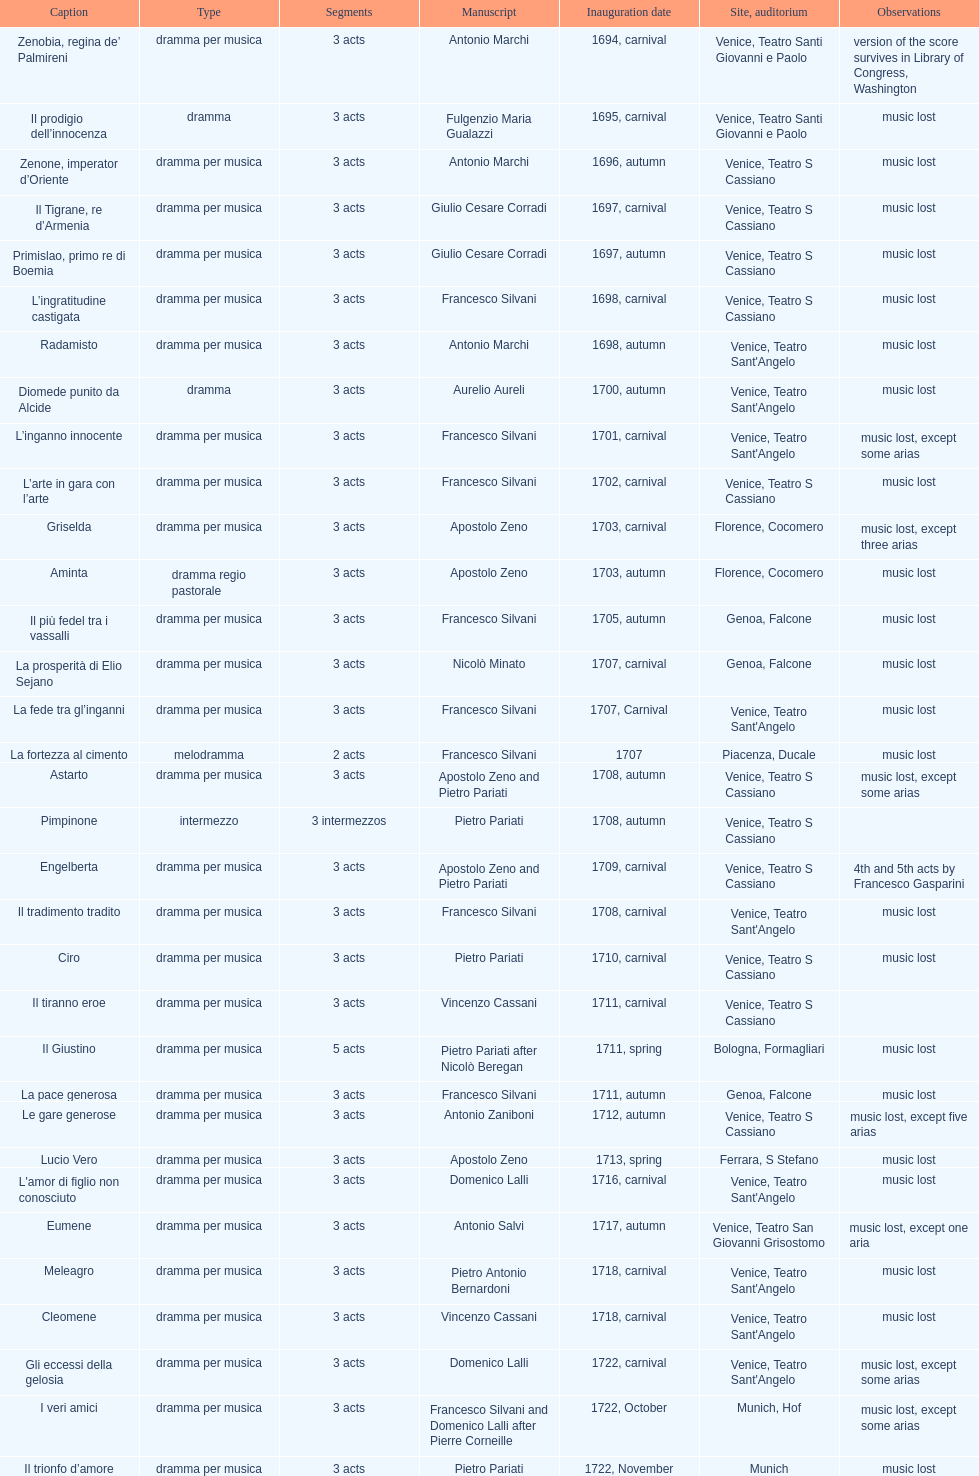I'm looking to parse the entire table for insights. Could you assist me with that? {'header': ['Caption', 'Type', 'Segments', 'Manuscript', 'Inauguration date', 'Site, auditorium', 'Observations'], 'rows': [['Zenobia, regina de’ Palmireni', 'dramma per musica', '3 acts', 'Antonio Marchi', '1694, carnival', 'Venice, Teatro Santi Giovanni e Paolo', 'version of the score survives in Library of Congress, Washington'], ['Il prodigio dell’innocenza', 'dramma', '3 acts', 'Fulgenzio Maria Gualazzi', '1695, carnival', 'Venice, Teatro Santi Giovanni e Paolo', 'music lost'], ['Zenone, imperator d’Oriente', 'dramma per musica', '3 acts', 'Antonio Marchi', '1696, autumn', 'Venice, Teatro S Cassiano', 'music lost'], ['Il Tigrane, re d’Armenia', 'dramma per musica', '3 acts', 'Giulio Cesare Corradi', '1697, carnival', 'Venice, Teatro S Cassiano', 'music lost'], ['Primislao, primo re di Boemia', 'dramma per musica', '3 acts', 'Giulio Cesare Corradi', '1697, autumn', 'Venice, Teatro S Cassiano', 'music lost'], ['L’ingratitudine castigata', 'dramma per musica', '3 acts', 'Francesco Silvani', '1698, carnival', 'Venice, Teatro S Cassiano', 'music lost'], ['Radamisto', 'dramma per musica', '3 acts', 'Antonio Marchi', '1698, autumn', "Venice, Teatro Sant'Angelo", 'music lost'], ['Diomede punito da Alcide', 'dramma', '3 acts', 'Aurelio Aureli', '1700, autumn', "Venice, Teatro Sant'Angelo", 'music lost'], ['L’inganno innocente', 'dramma per musica', '3 acts', 'Francesco Silvani', '1701, carnival', "Venice, Teatro Sant'Angelo", 'music lost, except some arias'], ['L’arte in gara con l’arte', 'dramma per musica', '3 acts', 'Francesco Silvani', '1702, carnival', 'Venice, Teatro S Cassiano', 'music lost'], ['Griselda', 'dramma per musica', '3 acts', 'Apostolo Zeno', '1703, carnival', 'Florence, Cocomero', 'music lost, except three arias'], ['Aminta', 'dramma regio pastorale', '3 acts', 'Apostolo Zeno', '1703, autumn', 'Florence, Cocomero', 'music lost'], ['Il più fedel tra i vassalli', 'dramma per musica', '3 acts', 'Francesco Silvani', '1705, autumn', 'Genoa, Falcone', 'music lost'], ['La prosperità di Elio Sejano', 'dramma per musica', '3 acts', 'Nicolò Minato', '1707, carnival', 'Genoa, Falcone', 'music lost'], ['La fede tra gl’inganni', 'dramma per musica', '3 acts', 'Francesco Silvani', '1707, Carnival', "Venice, Teatro Sant'Angelo", 'music lost'], ['La fortezza al cimento', 'melodramma', '2 acts', 'Francesco Silvani', '1707', 'Piacenza, Ducale', 'music lost'], ['Astarto', 'dramma per musica', '3 acts', 'Apostolo Zeno and Pietro Pariati', '1708, autumn', 'Venice, Teatro S Cassiano', 'music lost, except some arias'], ['Pimpinone', 'intermezzo', '3 intermezzos', 'Pietro Pariati', '1708, autumn', 'Venice, Teatro S Cassiano', ''], ['Engelberta', 'dramma per musica', '3 acts', 'Apostolo Zeno and Pietro Pariati', '1709, carnival', 'Venice, Teatro S Cassiano', '4th and 5th acts by Francesco Gasparini'], ['Il tradimento tradito', 'dramma per musica', '3 acts', 'Francesco Silvani', '1708, carnival', "Venice, Teatro Sant'Angelo", 'music lost'], ['Ciro', 'dramma per musica', '3 acts', 'Pietro Pariati', '1710, carnival', 'Venice, Teatro S Cassiano', 'music lost'], ['Il tiranno eroe', 'dramma per musica', '3 acts', 'Vincenzo Cassani', '1711, carnival', 'Venice, Teatro S Cassiano', ''], ['Il Giustino', 'dramma per musica', '5 acts', 'Pietro Pariati after Nicolò Beregan', '1711, spring', 'Bologna, Formagliari', 'music lost'], ['La pace generosa', 'dramma per musica', '3 acts', 'Francesco Silvani', '1711, autumn', 'Genoa, Falcone', 'music lost'], ['Le gare generose', 'dramma per musica', '3 acts', 'Antonio Zaniboni', '1712, autumn', 'Venice, Teatro S Cassiano', 'music lost, except five arias'], ['Lucio Vero', 'dramma per musica', '3 acts', 'Apostolo Zeno', '1713, spring', 'Ferrara, S Stefano', 'music lost'], ["L'amor di figlio non conosciuto", 'dramma per musica', '3 acts', 'Domenico Lalli', '1716, carnival', "Venice, Teatro Sant'Angelo", 'music lost'], ['Eumene', 'dramma per musica', '3 acts', 'Antonio Salvi', '1717, autumn', 'Venice, Teatro San Giovanni Grisostomo', 'music lost, except one aria'], ['Meleagro', 'dramma per musica', '3 acts', 'Pietro Antonio Bernardoni', '1718, carnival', "Venice, Teatro Sant'Angelo", 'music lost'], ['Cleomene', 'dramma per musica', '3 acts', 'Vincenzo Cassani', '1718, carnival', "Venice, Teatro Sant'Angelo", 'music lost'], ['Gli eccessi della gelosia', 'dramma per musica', '3 acts', 'Domenico Lalli', '1722, carnival', "Venice, Teatro Sant'Angelo", 'music lost, except some arias'], ['I veri amici', 'dramma per musica', '3 acts', 'Francesco Silvani and Domenico Lalli after Pierre Corneille', '1722, October', 'Munich, Hof', 'music lost, except some arias'], ['Il trionfo d’amore', 'dramma per musica', '3 acts', 'Pietro Pariati', '1722, November', 'Munich', 'music lost'], ['Eumene', 'dramma per musica', '3 acts', 'Apostolo Zeno', '1723, carnival', 'Venice, Teatro San Moisè', 'music lost, except 2 arias'], ['Ermengarda', 'dramma per musica', '3 acts', 'Antonio Maria Lucchini', '1723, autumn', 'Venice, Teatro San Moisè', 'music lost'], ['Antigono, tutore di Filippo, re di Macedonia', 'tragedia', '5 acts', 'Giovanni Piazzon', '1724, carnival', 'Venice, Teatro San Moisè', '5th act by Giovanni Porta, music lost'], ['Scipione nelle Spagne', 'dramma per musica', '3 acts', 'Apostolo Zeno', '1724, Ascension', 'Venice, Teatro San Samuele', 'music lost'], ['Laodice', 'dramma per musica', '3 acts', 'Angelo Schietti', '1724, autumn', 'Venice, Teatro San Moisè', 'music lost, except 2 arias'], ['Didone abbandonata', 'tragedia', '3 acts', 'Metastasio', '1725, carnival', 'Venice, Teatro S Cassiano', 'music lost'], ["L'impresario delle Isole Canarie", 'intermezzo', '2 acts', 'Metastasio', '1725, carnival', 'Venice, Teatro S Cassiano', 'music lost'], ['Alcina delusa da Ruggero', 'dramma per musica', '3 acts', 'Antonio Marchi', '1725, autumn', 'Venice, Teatro S Cassiano', 'music lost'], ['I rivali generosi', 'dramma per musica', '3 acts', 'Apostolo Zeno', '1725', 'Brescia, Nuovo', ''], ['La Statira', 'dramma per musica', '3 acts', 'Apostolo Zeno and Pietro Pariati', '1726, Carnival', 'Rome, Teatro Capranica', ''], ['Malsazio e Fiammetta', 'intermezzo', '', '', '1726, Carnival', 'Rome, Teatro Capranica', ''], ['Il trionfo di Armida', 'dramma per musica', '3 acts', 'Girolamo Colatelli after Torquato Tasso', '1726, autumn', 'Venice, Teatro San Moisè', 'music lost'], ['L’incostanza schernita', 'dramma comico-pastorale', '3 acts', 'Vincenzo Cassani', '1727, Ascension', 'Venice, Teatro San Samuele', 'music lost, except some arias'], ['Le due rivali in amore', 'dramma per musica', '3 acts', 'Aurelio Aureli', '1728, autumn', 'Venice, Teatro San Moisè', 'music lost'], ['Il Satrapone', 'intermezzo', '', 'Salvi', '1729', 'Parma, Omodeo', ''], ['Li stratagemmi amorosi', 'dramma per musica', '3 acts', 'F Passerini', '1730, carnival', 'Venice, Teatro San Moisè', 'music lost'], ['Elenia', 'dramma per musica', '3 acts', 'Luisa Bergalli', '1730, carnival', "Venice, Teatro Sant'Angelo", 'music lost'], ['Merope', 'dramma', '3 acts', 'Apostolo Zeno', '1731, autumn', 'Prague, Sporck Theater', 'mostly by Albinoni, music lost'], ['Il più infedel tra gli amanti', 'dramma per musica', '3 acts', 'Angelo Schietti', '1731, autumn', 'Treviso, Dolphin', 'music lost'], ['Ardelinda', 'dramma', '3 acts', 'Bartolomeo Vitturi', '1732, autumn', "Venice, Teatro Sant'Angelo", 'music lost, except five arias'], ['Candalide', 'dramma per musica', '3 acts', 'Bartolomeo Vitturi', '1734, carnival', "Venice, Teatro Sant'Angelo", 'music lost'], ['Artamene', 'dramma per musica', '3 acts', 'Bartolomeo Vitturi', '1741, carnival', "Venice, Teatro Sant'Angelo", 'music lost']]} Which was released earlier, artamene or merope? Merope. 